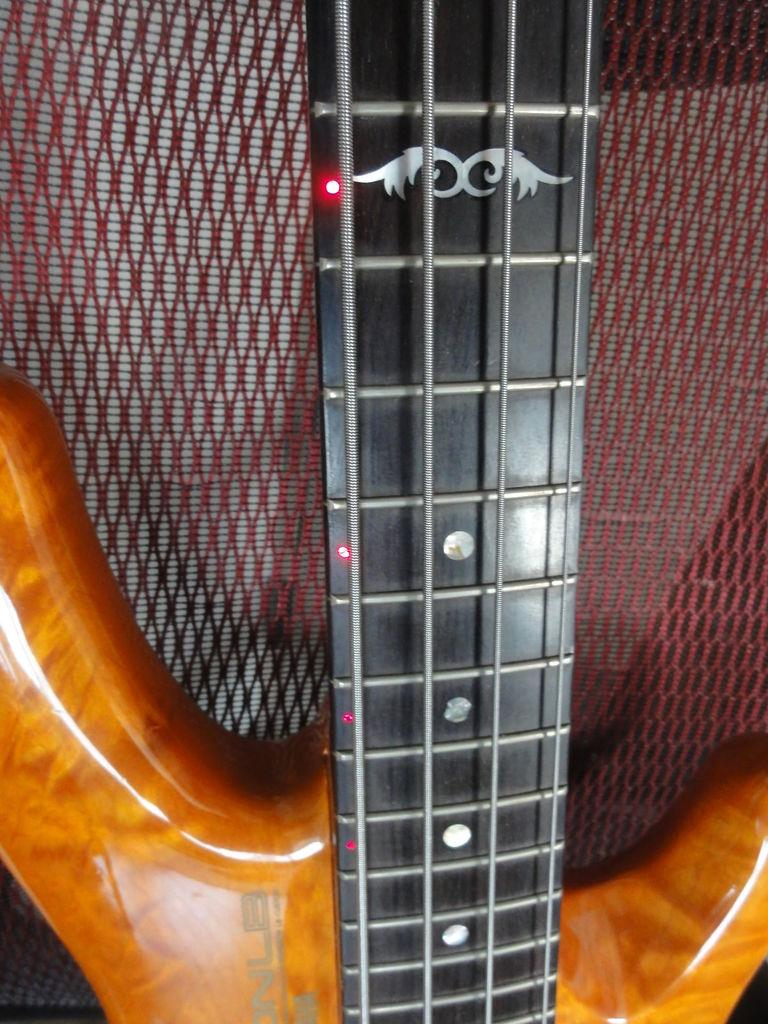What musical instrument is present in the image? There is a guitar in the image. What are the guitar's main components? The guitar has strings. Are there any additional features on the guitar? Yes, there are lights on the guitar. What type of animal is playing the guitar in the image? There is no animal playing the guitar in the image; it is a guitar without any visible person or animal interacting with it. 